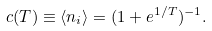<formula> <loc_0><loc_0><loc_500><loc_500>c ( T ) \equiv \langle n _ { i } \rangle = ( 1 + e ^ { 1 / T } ) ^ { - 1 } .</formula> 